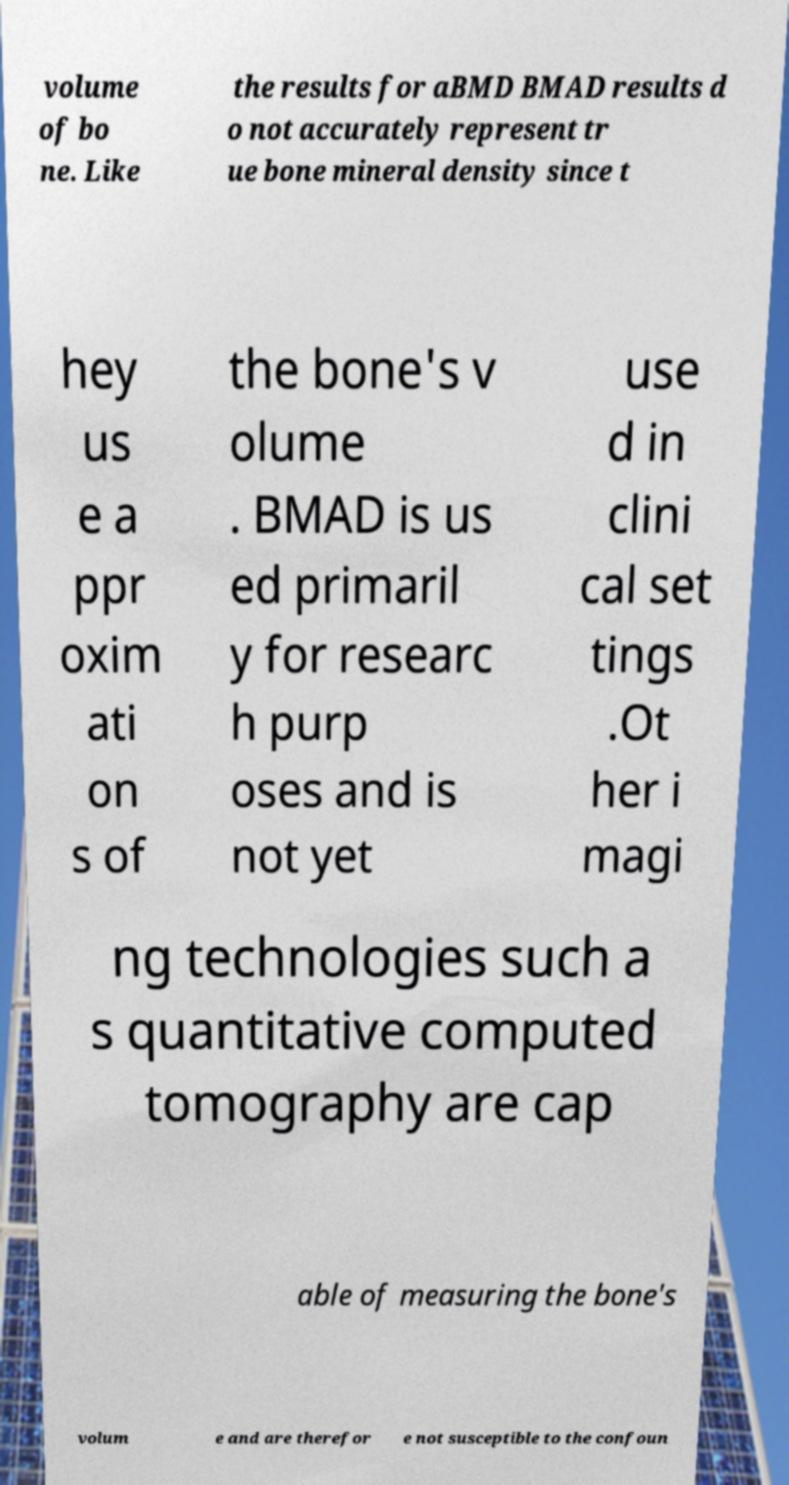What messages or text are displayed in this image? I need them in a readable, typed format. volume of bo ne. Like the results for aBMD BMAD results d o not accurately represent tr ue bone mineral density since t hey us e a ppr oxim ati on s of the bone's v olume . BMAD is us ed primaril y for researc h purp oses and is not yet use d in clini cal set tings .Ot her i magi ng technologies such a s quantitative computed tomography are cap able of measuring the bone's volum e and are therefor e not susceptible to the confoun 